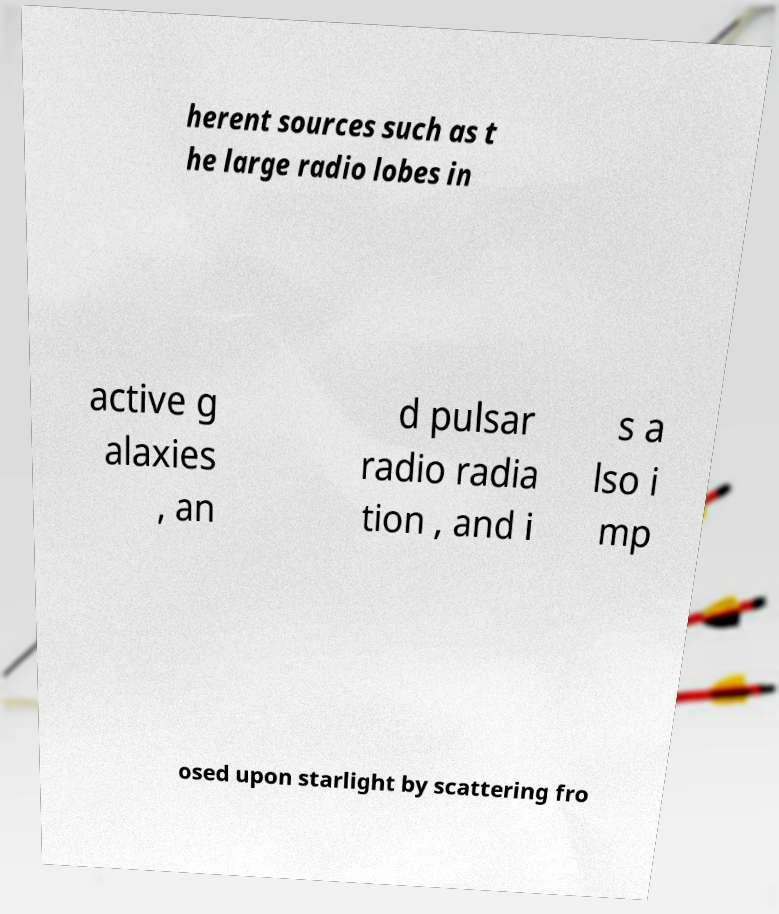What messages or text are displayed in this image? I need them in a readable, typed format. herent sources such as t he large radio lobes in active g alaxies , an d pulsar radio radia tion , and i s a lso i mp osed upon starlight by scattering fro 